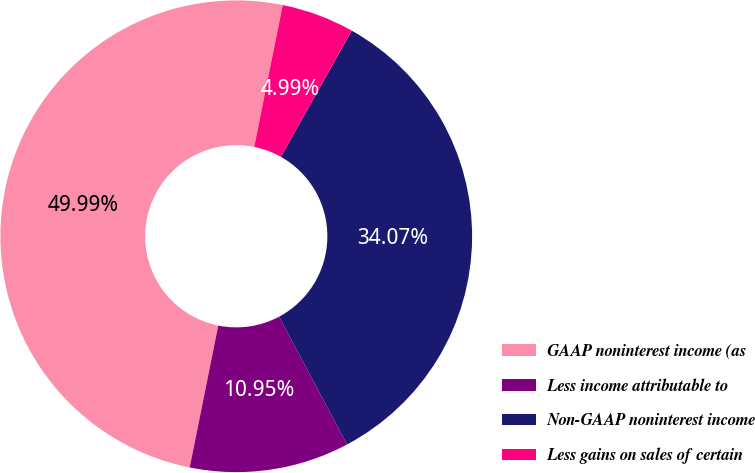<chart> <loc_0><loc_0><loc_500><loc_500><pie_chart><fcel>GAAP noninterest income (as<fcel>Less income attributable to<fcel>Non-GAAP noninterest income<fcel>Less gains on sales of certain<nl><fcel>50.0%<fcel>10.95%<fcel>34.07%<fcel>4.99%<nl></chart> 